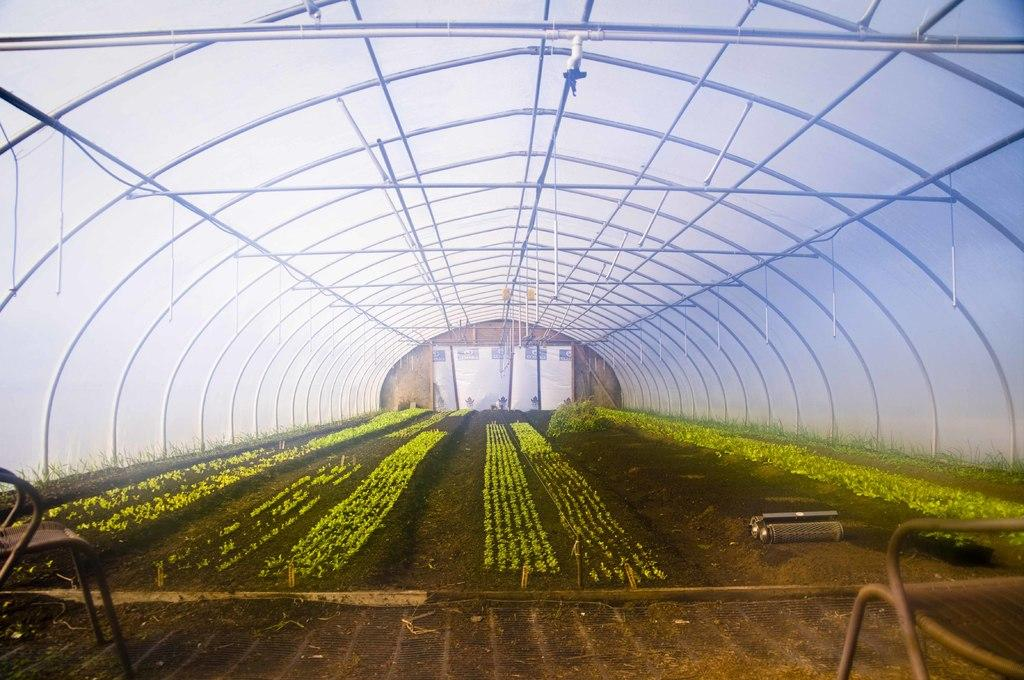What type of living organisms can be seen in the image? Plants can be seen in the image. What material are the bars in the image made of? The bars in the image are made of iron. What is the background of the image? There is a wall in the image. What type of jelly can be seen on the wall in the image? There is no jelly present on the wall in the image. How does the balloon affect the plants in the image? There is no balloon present in the image, so it cannot affect the plants. 